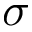Convert formula to latex. <formula><loc_0><loc_0><loc_500><loc_500>\sigma</formula> 